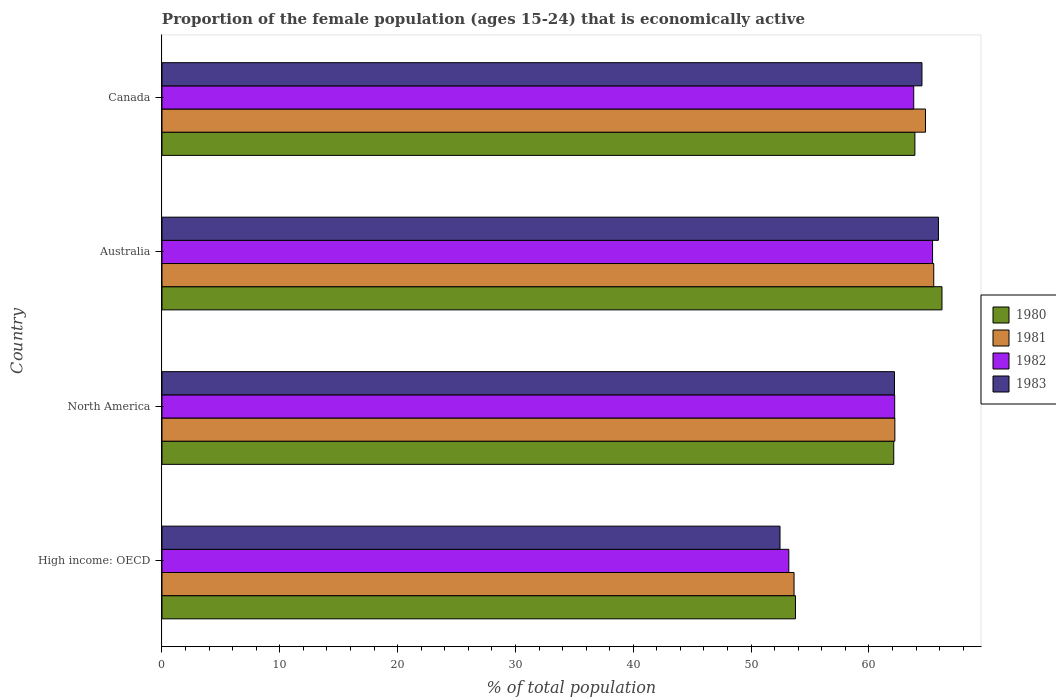How many groups of bars are there?
Your response must be concise. 4. How many bars are there on the 2nd tick from the top?
Provide a succinct answer. 4. What is the label of the 4th group of bars from the top?
Offer a terse response. High income: OECD. What is the proportion of the female population that is economically active in 1983 in Australia?
Your answer should be compact. 65.9. Across all countries, what is the maximum proportion of the female population that is economically active in 1983?
Your response must be concise. 65.9. Across all countries, what is the minimum proportion of the female population that is economically active in 1982?
Keep it short and to the point. 53.2. In which country was the proportion of the female population that is economically active in 1981 minimum?
Give a very brief answer. High income: OECD. What is the total proportion of the female population that is economically active in 1981 in the graph?
Give a very brief answer. 246.14. What is the difference between the proportion of the female population that is economically active in 1980 in Australia and that in North America?
Your answer should be very brief. 4.09. What is the difference between the proportion of the female population that is economically active in 1983 in Australia and the proportion of the female population that is economically active in 1981 in High income: OECD?
Provide a short and direct response. 12.26. What is the average proportion of the female population that is economically active in 1983 per country?
Keep it short and to the point. 61.26. What is the difference between the proportion of the female population that is economically active in 1982 and proportion of the female population that is economically active in 1981 in North America?
Your answer should be compact. -0.01. In how many countries, is the proportion of the female population that is economically active in 1982 greater than 52 %?
Offer a very short reply. 4. What is the ratio of the proportion of the female population that is economically active in 1982 in Australia to that in High income: OECD?
Provide a succinct answer. 1.23. What is the difference between the highest and the second highest proportion of the female population that is economically active in 1982?
Provide a short and direct response. 1.6. What is the difference between the highest and the lowest proportion of the female population that is economically active in 1981?
Keep it short and to the point. 11.86. What does the 4th bar from the bottom in Australia represents?
Provide a succinct answer. 1983. Is it the case that in every country, the sum of the proportion of the female population that is economically active in 1980 and proportion of the female population that is economically active in 1981 is greater than the proportion of the female population that is economically active in 1983?
Offer a terse response. Yes. Are the values on the major ticks of X-axis written in scientific E-notation?
Make the answer very short. No. Does the graph contain any zero values?
Keep it short and to the point. No. Does the graph contain grids?
Make the answer very short. No. How are the legend labels stacked?
Your answer should be compact. Vertical. What is the title of the graph?
Offer a terse response. Proportion of the female population (ages 15-24) that is economically active. Does "1961" appear as one of the legend labels in the graph?
Your response must be concise. No. What is the label or title of the X-axis?
Keep it short and to the point. % of total population. What is the label or title of the Y-axis?
Your response must be concise. Country. What is the % of total population in 1980 in High income: OECD?
Your answer should be very brief. 53.76. What is the % of total population of 1981 in High income: OECD?
Keep it short and to the point. 53.64. What is the % of total population of 1982 in High income: OECD?
Your answer should be very brief. 53.2. What is the % of total population in 1983 in High income: OECD?
Your answer should be compact. 52.45. What is the % of total population of 1980 in North America?
Keep it short and to the point. 62.11. What is the % of total population of 1981 in North America?
Offer a very short reply. 62.2. What is the % of total population in 1982 in North America?
Ensure brevity in your answer.  62.19. What is the % of total population of 1983 in North America?
Make the answer very short. 62.17. What is the % of total population of 1980 in Australia?
Your answer should be compact. 66.2. What is the % of total population of 1981 in Australia?
Provide a succinct answer. 65.5. What is the % of total population of 1982 in Australia?
Give a very brief answer. 65.4. What is the % of total population in 1983 in Australia?
Offer a very short reply. 65.9. What is the % of total population in 1980 in Canada?
Provide a succinct answer. 63.9. What is the % of total population of 1981 in Canada?
Give a very brief answer. 64.8. What is the % of total population in 1982 in Canada?
Your answer should be very brief. 63.8. What is the % of total population in 1983 in Canada?
Provide a succinct answer. 64.5. Across all countries, what is the maximum % of total population of 1980?
Ensure brevity in your answer.  66.2. Across all countries, what is the maximum % of total population of 1981?
Provide a short and direct response. 65.5. Across all countries, what is the maximum % of total population in 1982?
Ensure brevity in your answer.  65.4. Across all countries, what is the maximum % of total population of 1983?
Offer a terse response. 65.9. Across all countries, what is the minimum % of total population of 1980?
Your response must be concise. 53.76. Across all countries, what is the minimum % of total population of 1981?
Your answer should be very brief. 53.64. Across all countries, what is the minimum % of total population in 1982?
Provide a succinct answer. 53.2. Across all countries, what is the minimum % of total population in 1983?
Provide a succinct answer. 52.45. What is the total % of total population of 1980 in the graph?
Provide a succinct answer. 245.97. What is the total % of total population in 1981 in the graph?
Your answer should be compact. 246.14. What is the total % of total population in 1982 in the graph?
Your answer should be very brief. 244.58. What is the total % of total population in 1983 in the graph?
Provide a short and direct response. 245.02. What is the difference between the % of total population in 1980 in High income: OECD and that in North America?
Provide a succinct answer. -8.34. What is the difference between the % of total population of 1981 in High income: OECD and that in North America?
Keep it short and to the point. -8.56. What is the difference between the % of total population in 1982 in High income: OECD and that in North America?
Ensure brevity in your answer.  -8.99. What is the difference between the % of total population of 1983 in High income: OECD and that in North America?
Your answer should be very brief. -9.71. What is the difference between the % of total population of 1980 in High income: OECD and that in Australia?
Provide a succinct answer. -12.44. What is the difference between the % of total population of 1981 in High income: OECD and that in Australia?
Your response must be concise. -11.86. What is the difference between the % of total population of 1982 in High income: OECD and that in Australia?
Provide a short and direct response. -12.2. What is the difference between the % of total population of 1983 in High income: OECD and that in Australia?
Make the answer very short. -13.45. What is the difference between the % of total population in 1980 in High income: OECD and that in Canada?
Provide a succinct answer. -10.14. What is the difference between the % of total population of 1981 in High income: OECD and that in Canada?
Provide a short and direct response. -11.16. What is the difference between the % of total population of 1982 in High income: OECD and that in Canada?
Provide a short and direct response. -10.6. What is the difference between the % of total population in 1983 in High income: OECD and that in Canada?
Your answer should be compact. -12.05. What is the difference between the % of total population in 1980 in North America and that in Australia?
Make the answer very short. -4.09. What is the difference between the % of total population in 1981 in North America and that in Australia?
Offer a terse response. -3.3. What is the difference between the % of total population of 1982 in North America and that in Australia?
Keep it short and to the point. -3.21. What is the difference between the % of total population in 1983 in North America and that in Australia?
Offer a terse response. -3.73. What is the difference between the % of total population of 1980 in North America and that in Canada?
Your response must be concise. -1.79. What is the difference between the % of total population in 1981 in North America and that in Canada?
Provide a short and direct response. -2.6. What is the difference between the % of total population of 1982 in North America and that in Canada?
Provide a short and direct response. -1.61. What is the difference between the % of total population of 1983 in North America and that in Canada?
Offer a terse response. -2.33. What is the difference between the % of total population of 1980 in High income: OECD and the % of total population of 1981 in North America?
Provide a short and direct response. -8.44. What is the difference between the % of total population of 1980 in High income: OECD and the % of total population of 1982 in North America?
Your response must be concise. -8.42. What is the difference between the % of total population of 1980 in High income: OECD and the % of total population of 1983 in North America?
Keep it short and to the point. -8.4. What is the difference between the % of total population in 1981 in High income: OECD and the % of total population in 1982 in North America?
Make the answer very short. -8.54. What is the difference between the % of total population of 1981 in High income: OECD and the % of total population of 1983 in North America?
Provide a short and direct response. -8.52. What is the difference between the % of total population in 1982 in High income: OECD and the % of total population in 1983 in North America?
Make the answer very short. -8.97. What is the difference between the % of total population of 1980 in High income: OECD and the % of total population of 1981 in Australia?
Provide a succinct answer. -11.74. What is the difference between the % of total population in 1980 in High income: OECD and the % of total population in 1982 in Australia?
Your answer should be very brief. -11.64. What is the difference between the % of total population of 1980 in High income: OECD and the % of total population of 1983 in Australia?
Make the answer very short. -12.14. What is the difference between the % of total population of 1981 in High income: OECD and the % of total population of 1982 in Australia?
Keep it short and to the point. -11.76. What is the difference between the % of total population of 1981 in High income: OECD and the % of total population of 1983 in Australia?
Provide a short and direct response. -12.26. What is the difference between the % of total population of 1982 in High income: OECD and the % of total population of 1983 in Australia?
Provide a succinct answer. -12.7. What is the difference between the % of total population of 1980 in High income: OECD and the % of total population of 1981 in Canada?
Offer a terse response. -11.04. What is the difference between the % of total population of 1980 in High income: OECD and the % of total population of 1982 in Canada?
Ensure brevity in your answer.  -10.04. What is the difference between the % of total population in 1980 in High income: OECD and the % of total population in 1983 in Canada?
Your response must be concise. -10.74. What is the difference between the % of total population of 1981 in High income: OECD and the % of total population of 1982 in Canada?
Your answer should be very brief. -10.16. What is the difference between the % of total population in 1981 in High income: OECD and the % of total population in 1983 in Canada?
Give a very brief answer. -10.86. What is the difference between the % of total population in 1982 in High income: OECD and the % of total population in 1983 in Canada?
Ensure brevity in your answer.  -11.3. What is the difference between the % of total population of 1980 in North America and the % of total population of 1981 in Australia?
Provide a succinct answer. -3.39. What is the difference between the % of total population of 1980 in North America and the % of total population of 1982 in Australia?
Your answer should be very brief. -3.29. What is the difference between the % of total population of 1980 in North America and the % of total population of 1983 in Australia?
Offer a terse response. -3.79. What is the difference between the % of total population in 1981 in North America and the % of total population in 1982 in Australia?
Make the answer very short. -3.2. What is the difference between the % of total population of 1981 in North America and the % of total population of 1983 in Australia?
Offer a very short reply. -3.7. What is the difference between the % of total population in 1982 in North America and the % of total population in 1983 in Australia?
Offer a very short reply. -3.71. What is the difference between the % of total population in 1980 in North America and the % of total population in 1981 in Canada?
Ensure brevity in your answer.  -2.69. What is the difference between the % of total population of 1980 in North America and the % of total population of 1982 in Canada?
Provide a succinct answer. -1.69. What is the difference between the % of total population in 1980 in North America and the % of total population in 1983 in Canada?
Your answer should be very brief. -2.39. What is the difference between the % of total population of 1981 in North America and the % of total population of 1982 in Canada?
Offer a very short reply. -1.6. What is the difference between the % of total population in 1981 in North America and the % of total population in 1983 in Canada?
Your response must be concise. -2.3. What is the difference between the % of total population of 1982 in North America and the % of total population of 1983 in Canada?
Your answer should be very brief. -2.31. What is the difference between the % of total population of 1980 in Australia and the % of total population of 1982 in Canada?
Keep it short and to the point. 2.4. What is the difference between the % of total population in 1980 in Australia and the % of total population in 1983 in Canada?
Your response must be concise. 1.7. What is the difference between the % of total population of 1981 in Australia and the % of total population of 1982 in Canada?
Offer a very short reply. 1.7. What is the difference between the % of total population in 1981 in Australia and the % of total population in 1983 in Canada?
Keep it short and to the point. 1. What is the difference between the % of total population of 1982 in Australia and the % of total population of 1983 in Canada?
Provide a short and direct response. 0.9. What is the average % of total population of 1980 per country?
Your answer should be compact. 61.49. What is the average % of total population of 1981 per country?
Give a very brief answer. 61.54. What is the average % of total population of 1982 per country?
Your response must be concise. 61.15. What is the average % of total population in 1983 per country?
Give a very brief answer. 61.26. What is the difference between the % of total population in 1980 and % of total population in 1981 in High income: OECD?
Ensure brevity in your answer.  0.12. What is the difference between the % of total population of 1980 and % of total population of 1982 in High income: OECD?
Your answer should be compact. 0.57. What is the difference between the % of total population in 1980 and % of total population in 1983 in High income: OECD?
Keep it short and to the point. 1.31. What is the difference between the % of total population in 1981 and % of total population in 1982 in High income: OECD?
Ensure brevity in your answer.  0.44. What is the difference between the % of total population of 1981 and % of total population of 1983 in High income: OECD?
Provide a succinct answer. 1.19. What is the difference between the % of total population in 1982 and % of total population in 1983 in High income: OECD?
Offer a terse response. 0.75. What is the difference between the % of total population of 1980 and % of total population of 1981 in North America?
Offer a very short reply. -0.09. What is the difference between the % of total population of 1980 and % of total population of 1982 in North America?
Offer a very short reply. -0.08. What is the difference between the % of total population in 1980 and % of total population in 1983 in North America?
Make the answer very short. -0.06. What is the difference between the % of total population of 1981 and % of total population of 1982 in North America?
Ensure brevity in your answer.  0.01. What is the difference between the % of total population in 1981 and % of total population in 1983 in North America?
Make the answer very short. 0.03. What is the difference between the % of total population in 1982 and % of total population in 1983 in North America?
Give a very brief answer. 0.02. What is the difference between the % of total population of 1980 and % of total population of 1981 in Australia?
Ensure brevity in your answer.  0.7. What is the difference between the % of total population of 1981 and % of total population of 1982 in Australia?
Ensure brevity in your answer.  0.1. What is the difference between the % of total population in 1980 and % of total population in 1981 in Canada?
Ensure brevity in your answer.  -0.9. What is the difference between the % of total population of 1980 and % of total population of 1982 in Canada?
Make the answer very short. 0.1. What is the difference between the % of total population of 1980 and % of total population of 1983 in Canada?
Give a very brief answer. -0.6. What is the difference between the % of total population in 1981 and % of total population in 1982 in Canada?
Give a very brief answer. 1. What is the difference between the % of total population in 1982 and % of total population in 1983 in Canada?
Your answer should be very brief. -0.7. What is the ratio of the % of total population of 1980 in High income: OECD to that in North America?
Your response must be concise. 0.87. What is the ratio of the % of total population of 1981 in High income: OECD to that in North America?
Make the answer very short. 0.86. What is the ratio of the % of total population of 1982 in High income: OECD to that in North America?
Give a very brief answer. 0.86. What is the ratio of the % of total population in 1983 in High income: OECD to that in North America?
Ensure brevity in your answer.  0.84. What is the ratio of the % of total population in 1980 in High income: OECD to that in Australia?
Provide a short and direct response. 0.81. What is the ratio of the % of total population of 1981 in High income: OECD to that in Australia?
Your response must be concise. 0.82. What is the ratio of the % of total population in 1982 in High income: OECD to that in Australia?
Make the answer very short. 0.81. What is the ratio of the % of total population in 1983 in High income: OECD to that in Australia?
Make the answer very short. 0.8. What is the ratio of the % of total population of 1980 in High income: OECD to that in Canada?
Keep it short and to the point. 0.84. What is the ratio of the % of total population in 1981 in High income: OECD to that in Canada?
Provide a succinct answer. 0.83. What is the ratio of the % of total population of 1982 in High income: OECD to that in Canada?
Offer a terse response. 0.83. What is the ratio of the % of total population in 1983 in High income: OECD to that in Canada?
Ensure brevity in your answer.  0.81. What is the ratio of the % of total population of 1980 in North America to that in Australia?
Keep it short and to the point. 0.94. What is the ratio of the % of total population of 1981 in North America to that in Australia?
Make the answer very short. 0.95. What is the ratio of the % of total population in 1982 in North America to that in Australia?
Keep it short and to the point. 0.95. What is the ratio of the % of total population of 1983 in North America to that in Australia?
Keep it short and to the point. 0.94. What is the ratio of the % of total population of 1980 in North America to that in Canada?
Keep it short and to the point. 0.97. What is the ratio of the % of total population in 1981 in North America to that in Canada?
Ensure brevity in your answer.  0.96. What is the ratio of the % of total population of 1982 in North America to that in Canada?
Make the answer very short. 0.97. What is the ratio of the % of total population of 1983 in North America to that in Canada?
Offer a terse response. 0.96. What is the ratio of the % of total population in 1980 in Australia to that in Canada?
Keep it short and to the point. 1.04. What is the ratio of the % of total population in 1981 in Australia to that in Canada?
Your answer should be very brief. 1.01. What is the ratio of the % of total population of 1982 in Australia to that in Canada?
Make the answer very short. 1.03. What is the ratio of the % of total population of 1983 in Australia to that in Canada?
Offer a very short reply. 1.02. What is the difference between the highest and the second highest % of total population in 1980?
Make the answer very short. 2.3. What is the difference between the highest and the second highest % of total population in 1982?
Ensure brevity in your answer.  1.6. What is the difference between the highest and the lowest % of total population in 1980?
Offer a terse response. 12.44. What is the difference between the highest and the lowest % of total population of 1981?
Keep it short and to the point. 11.86. What is the difference between the highest and the lowest % of total population of 1982?
Provide a succinct answer. 12.2. What is the difference between the highest and the lowest % of total population in 1983?
Make the answer very short. 13.45. 